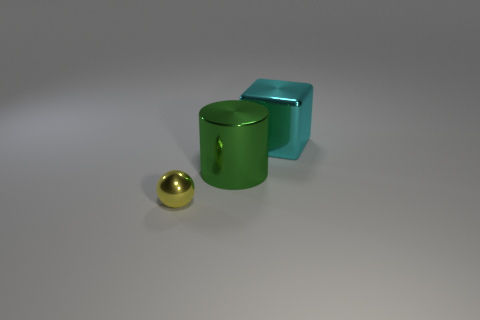Are there more yellow metal cylinders than green objects?
Ensure brevity in your answer.  No. There is a metallic object that is on the right side of the large green cylinder; what number of tiny spheres are behind it?
Provide a succinct answer. 0. How many things are objects that are behind the yellow metal ball or tiny red metal cylinders?
Your response must be concise. 2. Are there any other big things that have the same shape as the cyan metal object?
Offer a very short reply. No. What shape is the shiny object that is left of the big object that is left of the cyan block?
Your answer should be very brief. Sphere. How many cylinders are either small cyan rubber things or big green objects?
Your answer should be compact. 1. Is the shape of the large metallic object in front of the big cube the same as the object that is in front of the big green thing?
Your answer should be compact. No. What is the color of the thing that is both on the left side of the big cyan metallic thing and behind the shiny ball?
Provide a short and direct response. Green. Does the big shiny cylinder have the same color as the thing in front of the cylinder?
Ensure brevity in your answer.  No. What is the size of the thing that is both to the left of the block and behind the small ball?
Provide a short and direct response. Large. 